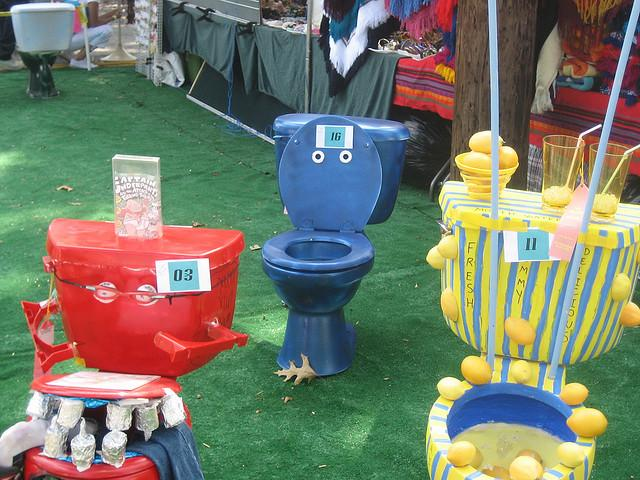The artistically displayed items here are normally connected to what? Please explain your reasoning. plumbing. These are toilets 